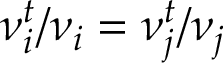<formula> <loc_0><loc_0><loc_500><loc_500>\nu _ { i } ^ { t } / \nu _ { i } = \nu _ { j } ^ { t } / \nu _ { j }</formula> 